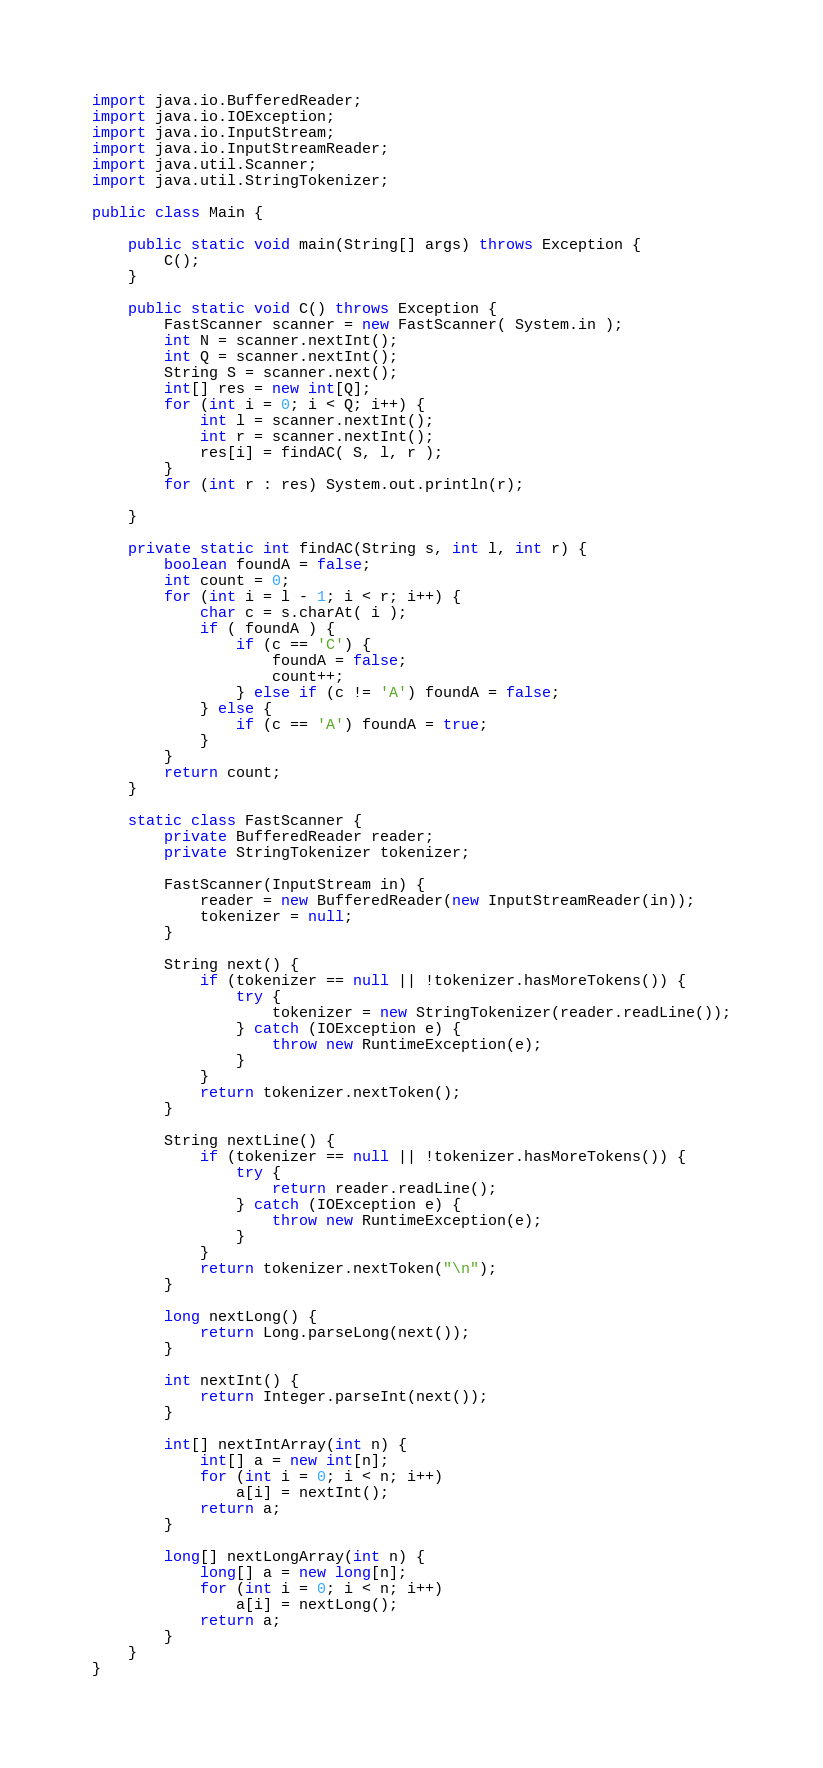Convert code to text. <code><loc_0><loc_0><loc_500><loc_500><_Java_>import java.io.BufferedReader;
import java.io.IOException;
import java.io.InputStream;
import java.io.InputStreamReader;
import java.util.Scanner;
import java.util.StringTokenizer;

public class Main {

    public static void main(String[] args) throws Exception {
        C();
    }

    public static void C() throws Exception {
        FastScanner scanner = new FastScanner( System.in );
        int N = scanner.nextInt();
        int Q = scanner.nextInt();
        String S = scanner.next();
        int[] res = new int[Q];
        for (int i = 0; i < Q; i++) {
            int l = scanner.nextInt();
            int r = scanner.nextInt();
            res[i] = findAC( S, l, r );
        }
        for (int r : res) System.out.println(r);

    }

    private static int findAC(String s, int l, int r) {
        boolean foundA = false;
        int count = 0;
        for (int i = l - 1; i < r; i++) {
            char c = s.charAt( i );
            if ( foundA ) {
                if (c == 'C') {
                    foundA = false;
                    count++;
                } else if (c != 'A') foundA = false;
            } else {
                if (c == 'A') foundA = true;
            }
        }
        return count;
    }

    static class FastScanner {
        private BufferedReader reader;
        private StringTokenizer tokenizer;

        FastScanner(InputStream in) {
            reader = new BufferedReader(new InputStreamReader(in));
            tokenizer = null;
        }

        String next() {
            if (tokenizer == null || !tokenizer.hasMoreTokens()) {
                try {
                    tokenizer = new StringTokenizer(reader.readLine());
                } catch (IOException e) {
                    throw new RuntimeException(e);
                }
            }
            return tokenizer.nextToken();
        }

        String nextLine() {
            if (tokenizer == null || !tokenizer.hasMoreTokens()) {
                try {
                    return reader.readLine();
                } catch (IOException e) {
                    throw new RuntimeException(e);
                }
            }
            return tokenizer.nextToken("\n");
        }

        long nextLong() {
            return Long.parseLong(next());
        }

        int nextInt() {
            return Integer.parseInt(next());
        }

        int[] nextIntArray(int n) {
            int[] a = new int[n];
            for (int i = 0; i < n; i++)
                a[i] = nextInt();
            return a;
        }

        long[] nextLongArray(int n) {
            long[] a = new long[n];
            for (int i = 0; i < n; i++)
                a[i] = nextLong();
            return a;
        }
    }
}
</code> 